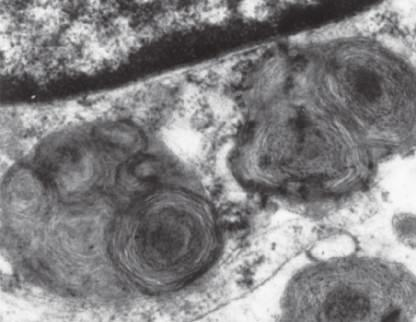does immunoperoxidase show prominent lysosomes with whorled configurations just below part of the nucleus?
Answer the question using a single word or phrase. No 